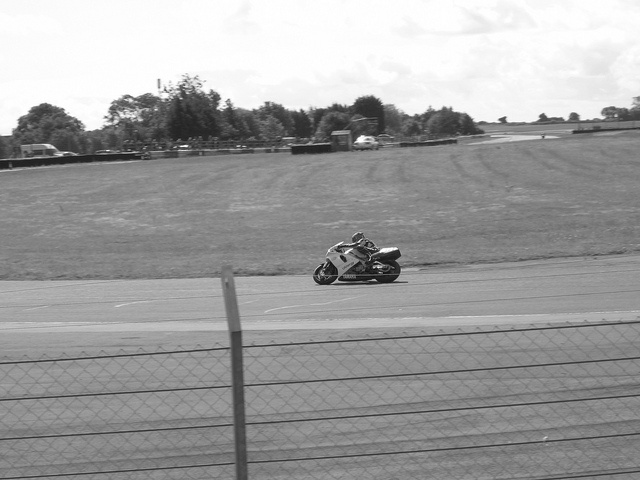Describe the objects in this image and their specific colors. I can see motorcycle in white, black, gray, and lightgray tones, truck in white, gray, darkgray, black, and lightgray tones, people in white, gray, black, darkgray, and lightgray tones, car in white, gray, darkgray, lightgray, and black tones, and car in gray, black, and white tones in this image. 